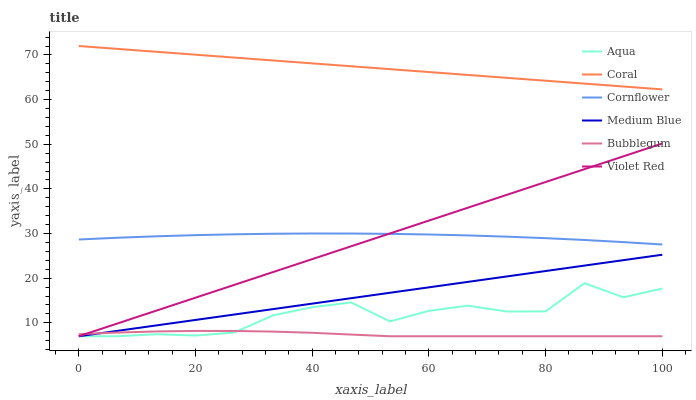Does Violet Red have the minimum area under the curve?
Answer yes or no. No. Does Violet Red have the maximum area under the curve?
Answer yes or no. No. Is Violet Red the smoothest?
Answer yes or no. No. Is Violet Red the roughest?
Answer yes or no. No. Does Coral have the lowest value?
Answer yes or no. No. Does Violet Red have the highest value?
Answer yes or no. No. Is Aqua less than Coral?
Answer yes or no. Yes. Is Coral greater than Violet Red?
Answer yes or no. Yes. Does Aqua intersect Coral?
Answer yes or no. No. 